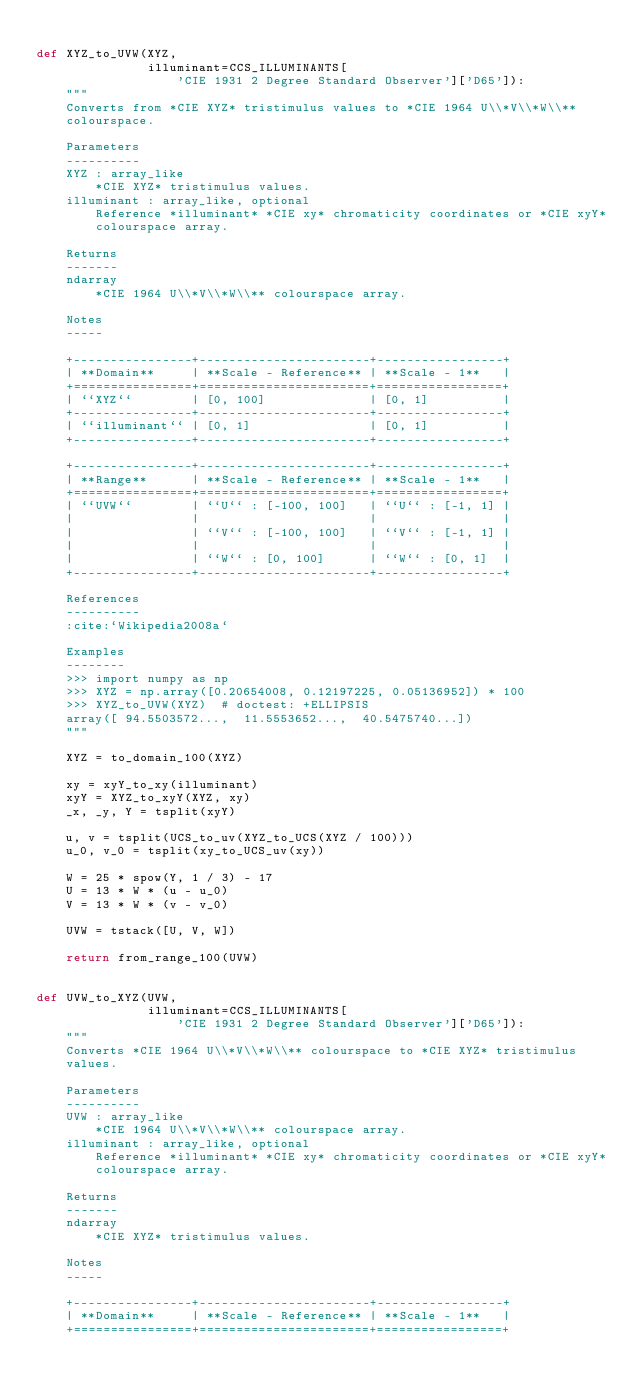Convert code to text. <code><loc_0><loc_0><loc_500><loc_500><_Python_>
def XYZ_to_UVW(XYZ,
               illuminant=CCS_ILLUMINANTS[
                   'CIE 1931 2 Degree Standard Observer']['D65']):
    """
    Converts from *CIE XYZ* tristimulus values to *CIE 1964 U\\*V\\*W\\**
    colourspace.

    Parameters
    ----------
    XYZ : array_like
        *CIE XYZ* tristimulus values.
    illuminant : array_like, optional
        Reference *illuminant* *CIE xy* chromaticity coordinates or *CIE xyY*
        colourspace array.

    Returns
    -------
    ndarray
        *CIE 1964 U\\*V\\*W\\** colourspace array.

    Notes
    -----

    +----------------+-----------------------+-----------------+
    | **Domain**     | **Scale - Reference** | **Scale - 1**   |
    +================+=======================+=================+
    | ``XYZ``        | [0, 100]              | [0, 1]          |
    +----------------+-----------------------+-----------------+
    | ``illuminant`` | [0, 1]                | [0, 1]          |
    +----------------+-----------------------+-----------------+

    +----------------+-----------------------+-----------------+
    | **Range**      | **Scale - Reference** | **Scale - 1**   |
    +================+=======================+=================+
    | ``UVW``        | ``U`` : [-100, 100]   | ``U`` : [-1, 1] |
    |                |                       |                 |
    |                | ``V`` : [-100, 100]   | ``V`` : [-1, 1] |
    |                |                       |                 |
    |                | ``W`` : [0, 100]      | ``W`` : [0, 1]  |
    +----------------+-----------------------+-----------------+

    References
    ----------
    :cite:`Wikipedia2008a`

    Examples
    --------
    >>> import numpy as np
    >>> XYZ = np.array([0.20654008, 0.12197225, 0.05136952]) * 100
    >>> XYZ_to_UVW(XYZ)  # doctest: +ELLIPSIS
    array([ 94.5503572...,  11.5553652...,  40.5475740...])
    """

    XYZ = to_domain_100(XYZ)

    xy = xyY_to_xy(illuminant)
    xyY = XYZ_to_xyY(XYZ, xy)
    _x, _y, Y = tsplit(xyY)

    u, v = tsplit(UCS_to_uv(XYZ_to_UCS(XYZ / 100)))
    u_0, v_0 = tsplit(xy_to_UCS_uv(xy))

    W = 25 * spow(Y, 1 / 3) - 17
    U = 13 * W * (u - u_0)
    V = 13 * W * (v - v_0)

    UVW = tstack([U, V, W])

    return from_range_100(UVW)


def UVW_to_XYZ(UVW,
               illuminant=CCS_ILLUMINANTS[
                   'CIE 1931 2 Degree Standard Observer']['D65']):
    """
    Converts *CIE 1964 U\\*V\\*W\\** colourspace to *CIE XYZ* tristimulus
    values.

    Parameters
    ----------
    UVW : array_like
        *CIE 1964 U\\*V\\*W\\** colourspace array.
    illuminant : array_like, optional
        Reference *illuminant* *CIE xy* chromaticity coordinates or *CIE xyY*
        colourspace array.

    Returns
    -------
    ndarray
        *CIE XYZ* tristimulus values.

    Notes
    -----

    +----------------+-----------------------+-----------------+
    | **Domain**     | **Scale - Reference** | **Scale - 1**   |
    +================+=======================+=================+</code> 